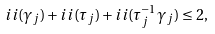Convert formula to latex. <formula><loc_0><loc_0><loc_500><loc_500>i i ( \gamma _ { j } ) + i i ( \tau _ { j } ) + i i ( \tau _ { j } ^ { - 1 } \gamma _ { j } ) \leq 2 ,</formula> 